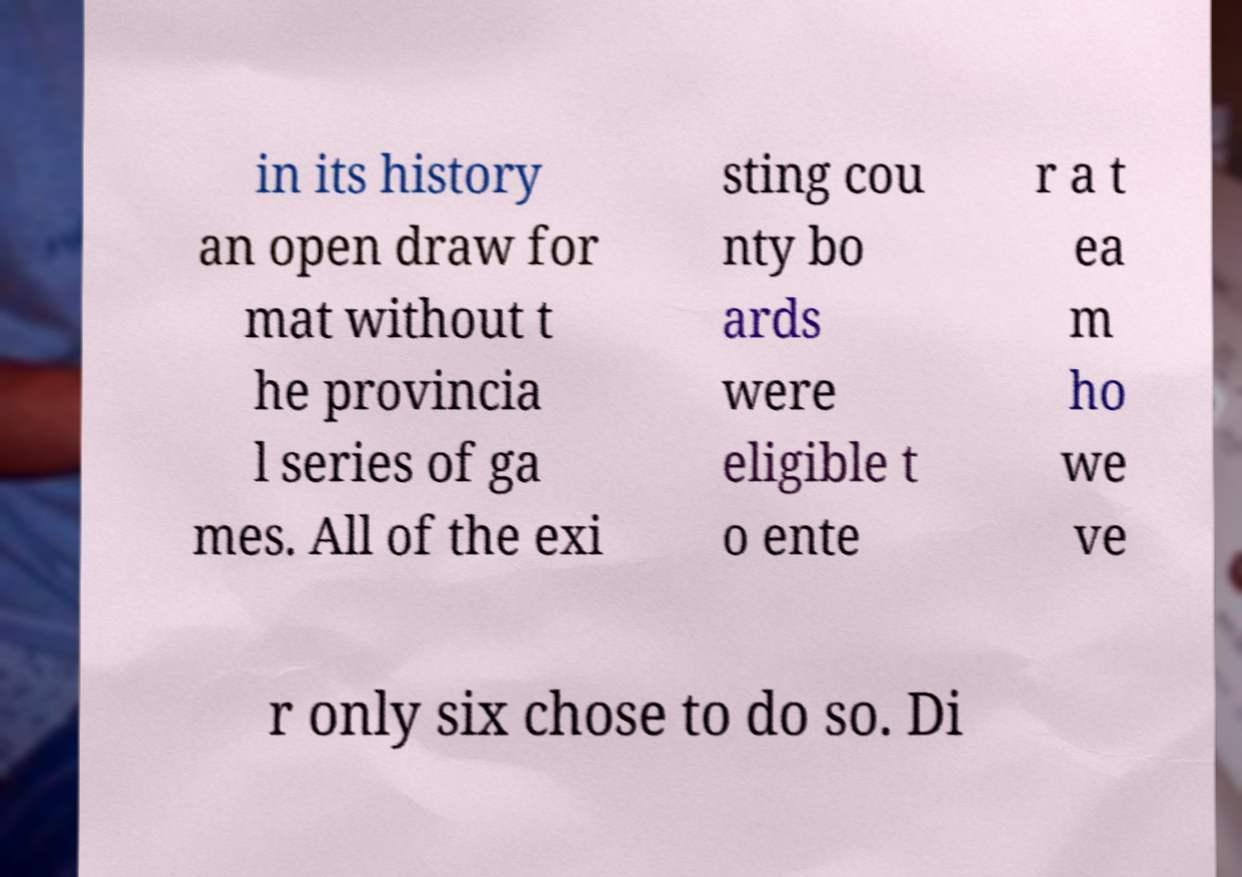Could you extract and type out the text from this image? in its history an open draw for mat without t he provincia l series of ga mes. All of the exi sting cou nty bo ards were eligible t o ente r a t ea m ho we ve r only six chose to do so. Di 